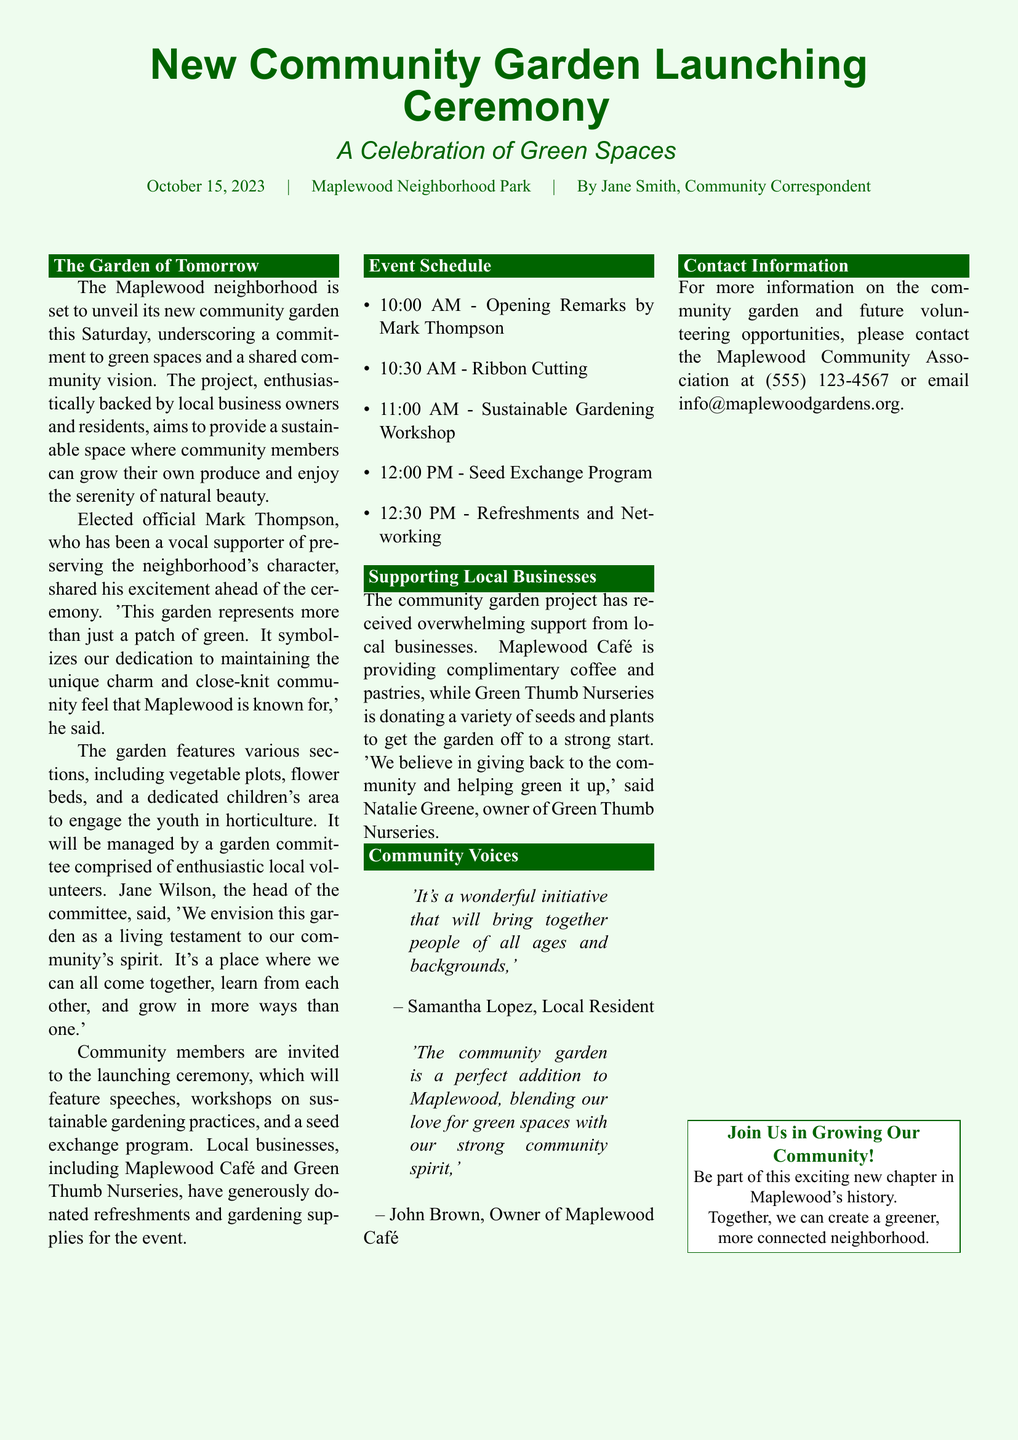What is the date of the launching ceremony? The launching ceremony is scheduled for October 15, 2023, as mentioned in the document.
Answer: October 15, 2023 Who is the head of the garden committee? The head of the garden committee is Jane Wilson, who is quoted in the document.
Answer: Jane Wilson What time does the ribbon cutting start? The ribbon cutting is scheduled to begin at 10:30 AM, which is indicated in the event schedule.
Answer: 10:30 AM Which local business is providing complimentary coffee? The document states that Maplewood Café is providing complimentary coffee for the event.
Answer: Maplewood Café What is the main theme of the event? The event is centered around a celebration of green spaces, as stated in the title of the document.
Answer: Celebration of Green Spaces How will the community garden be managed? It will be managed by a garden committee comprised of enthusiastic local volunteers, according to the details provided.
Answer: Local volunteers Who is the elected official mentioned in the document? The elected official discussed in the document is Mark Thompson, who supports the community garden project.
Answer: Mark Thompson What is included in the seed exchange program? The document mentions a seed exchange program will take place, although it doesn't list specifics. The focus is on community involvement.
Answer: Seed exchange program What color is the background of the page? The page background is described as a light green shade (lightgreen!15) in the document.
Answer: Light green 